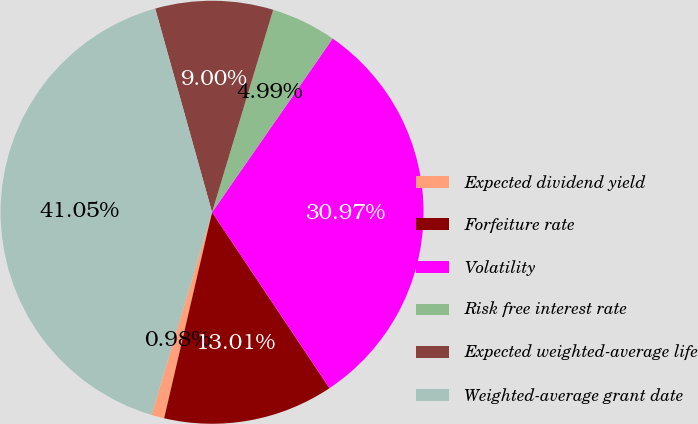Convert chart to OTSL. <chart><loc_0><loc_0><loc_500><loc_500><pie_chart><fcel>Expected dividend yield<fcel>Forfeiture rate<fcel>Volatility<fcel>Risk free interest rate<fcel>Expected weighted-average life<fcel>Weighted-average grant date<nl><fcel>0.98%<fcel>13.01%<fcel>30.97%<fcel>4.99%<fcel>9.0%<fcel>41.05%<nl></chart> 